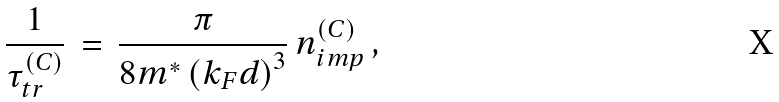Convert formula to latex. <formula><loc_0><loc_0><loc_500><loc_500>\, \frac { 1 } { \tau _ { t r } ^ { ( C ) } } \, = \, \frac { \pi } { 8 m ^ { * } \left ( k _ { F } d \right ) ^ { 3 } } \, n ^ { ( C ) } _ { i m p } \, ,</formula> 